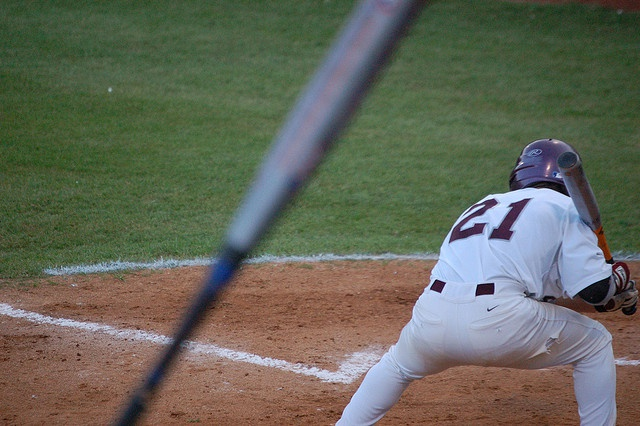Describe the objects in this image and their specific colors. I can see people in darkgreen, darkgray, lavender, and gray tones, baseball bat in darkgreen, gray, and black tones, and baseball bat in darkgreen, black, gray, and maroon tones in this image. 